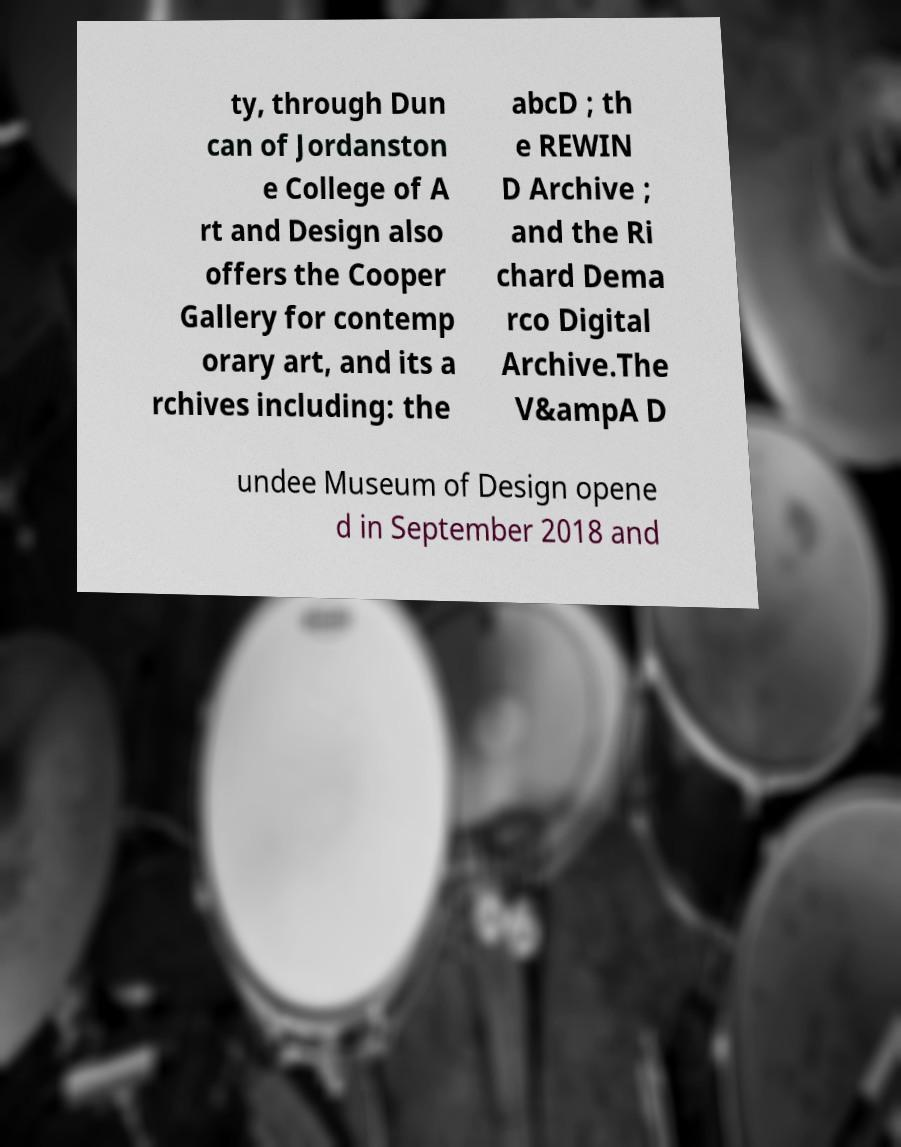Can you accurately transcribe the text from the provided image for me? ty, through Dun can of Jordanston e College of A rt and Design also offers the Cooper Gallery for contemp orary art, and its a rchives including: the abcD ; th e REWIN D Archive ; and the Ri chard Dema rco Digital Archive.The V&ampA D undee Museum of Design opene d in September 2018 and 